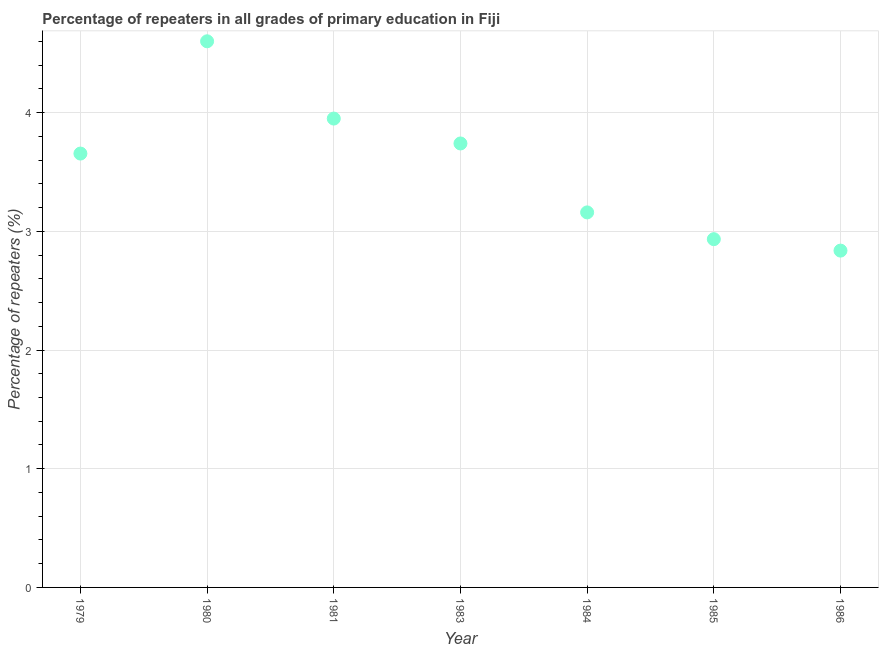What is the percentage of repeaters in primary education in 1983?
Make the answer very short. 3.74. Across all years, what is the maximum percentage of repeaters in primary education?
Ensure brevity in your answer.  4.6. Across all years, what is the minimum percentage of repeaters in primary education?
Give a very brief answer. 2.84. In which year was the percentage of repeaters in primary education maximum?
Offer a very short reply. 1980. In which year was the percentage of repeaters in primary education minimum?
Make the answer very short. 1986. What is the sum of the percentage of repeaters in primary education?
Offer a very short reply. 24.88. What is the difference between the percentage of repeaters in primary education in 1983 and 1986?
Make the answer very short. 0.9. What is the average percentage of repeaters in primary education per year?
Provide a short and direct response. 3.55. What is the median percentage of repeaters in primary education?
Your answer should be very brief. 3.66. What is the ratio of the percentage of repeaters in primary education in 1983 to that in 1984?
Your answer should be compact. 1.18. Is the percentage of repeaters in primary education in 1979 less than that in 1983?
Provide a short and direct response. Yes. Is the difference between the percentage of repeaters in primary education in 1981 and 1986 greater than the difference between any two years?
Keep it short and to the point. No. What is the difference between the highest and the second highest percentage of repeaters in primary education?
Your answer should be compact. 0.65. Is the sum of the percentage of repeaters in primary education in 1984 and 1985 greater than the maximum percentage of repeaters in primary education across all years?
Your answer should be very brief. Yes. What is the difference between the highest and the lowest percentage of repeaters in primary education?
Your response must be concise. 1.76. In how many years, is the percentage of repeaters in primary education greater than the average percentage of repeaters in primary education taken over all years?
Provide a succinct answer. 4. Does the percentage of repeaters in primary education monotonically increase over the years?
Offer a very short reply. No. How many dotlines are there?
Your answer should be very brief. 1. What is the difference between two consecutive major ticks on the Y-axis?
Provide a succinct answer. 1. Does the graph contain any zero values?
Ensure brevity in your answer.  No. Does the graph contain grids?
Your answer should be very brief. Yes. What is the title of the graph?
Provide a short and direct response. Percentage of repeaters in all grades of primary education in Fiji. What is the label or title of the Y-axis?
Your answer should be compact. Percentage of repeaters (%). What is the Percentage of repeaters (%) in 1979?
Offer a very short reply. 3.66. What is the Percentage of repeaters (%) in 1980?
Provide a short and direct response. 4.6. What is the Percentage of repeaters (%) in 1981?
Ensure brevity in your answer.  3.95. What is the Percentage of repeaters (%) in 1983?
Ensure brevity in your answer.  3.74. What is the Percentage of repeaters (%) in 1984?
Offer a terse response. 3.16. What is the Percentage of repeaters (%) in 1985?
Make the answer very short. 2.93. What is the Percentage of repeaters (%) in 1986?
Your answer should be compact. 2.84. What is the difference between the Percentage of repeaters (%) in 1979 and 1980?
Ensure brevity in your answer.  -0.95. What is the difference between the Percentage of repeaters (%) in 1979 and 1981?
Your answer should be very brief. -0.29. What is the difference between the Percentage of repeaters (%) in 1979 and 1983?
Provide a short and direct response. -0.09. What is the difference between the Percentage of repeaters (%) in 1979 and 1984?
Provide a short and direct response. 0.5. What is the difference between the Percentage of repeaters (%) in 1979 and 1985?
Your response must be concise. 0.72. What is the difference between the Percentage of repeaters (%) in 1979 and 1986?
Provide a succinct answer. 0.82. What is the difference between the Percentage of repeaters (%) in 1980 and 1981?
Offer a terse response. 0.65. What is the difference between the Percentage of repeaters (%) in 1980 and 1983?
Provide a succinct answer. 0.86. What is the difference between the Percentage of repeaters (%) in 1980 and 1984?
Make the answer very short. 1.44. What is the difference between the Percentage of repeaters (%) in 1980 and 1985?
Make the answer very short. 1.67. What is the difference between the Percentage of repeaters (%) in 1980 and 1986?
Your answer should be compact. 1.76. What is the difference between the Percentage of repeaters (%) in 1981 and 1983?
Make the answer very short. 0.21. What is the difference between the Percentage of repeaters (%) in 1981 and 1984?
Ensure brevity in your answer.  0.79. What is the difference between the Percentage of repeaters (%) in 1981 and 1985?
Keep it short and to the point. 1.02. What is the difference between the Percentage of repeaters (%) in 1981 and 1986?
Give a very brief answer. 1.11. What is the difference between the Percentage of repeaters (%) in 1983 and 1984?
Provide a succinct answer. 0.58. What is the difference between the Percentage of repeaters (%) in 1983 and 1985?
Your response must be concise. 0.81. What is the difference between the Percentage of repeaters (%) in 1983 and 1986?
Give a very brief answer. 0.9. What is the difference between the Percentage of repeaters (%) in 1984 and 1985?
Your response must be concise. 0.23. What is the difference between the Percentage of repeaters (%) in 1984 and 1986?
Provide a succinct answer. 0.32. What is the difference between the Percentage of repeaters (%) in 1985 and 1986?
Ensure brevity in your answer.  0.1. What is the ratio of the Percentage of repeaters (%) in 1979 to that in 1980?
Ensure brevity in your answer.  0.79. What is the ratio of the Percentage of repeaters (%) in 1979 to that in 1981?
Offer a terse response. 0.93. What is the ratio of the Percentage of repeaters (%) in 1979 to that in 1984?
Give a very brief answer. 1.16. What is the ratio of the Percentage of repeaters (%) in 1979 to that in 1985?
Provide a short and direct response. 1.25. What is the ratio of the Percentage of repeaters (%) in 1979 to that in 1986?
Make the answer very short. 1.29. What is the ratio of the Percentage of repeaters (%) in 1980 to that in 1981?
Provide a short and direct response. 1.17. What is the ratio of the Percentage of repeaters (%) in 1980 to that in 1983?
Give a very brief answer. 1.23. What is the ratio of the Percentage of repeaters (%) in 1980 to that in 1984?
Provide a succinct answer. 1.46. What is the ratio of the Percentage of repeaters (%) in 1980 to that in 1985?
Make the answer very short. 1.57. What is the ratio of the Percentage of repeaters (%) in 1980 to that in 1986?
Your response must be concise. 1.62. What is the ratio of the Percentage of repeaters (%) in 1981 to that in 1983?
Provide a succinct answer. 1.06. What is the ratio of the Percentage of repeaters (%) in 1981 to that in 1984?
Your answer should be very brief. 1.25. What is the ratio of the Percentage of repeaters (%) in 1981 to that in 1985?
Offer a terse response. 1.35. What is the ratio of the Percentage of repeaters (%) in 1981 to that in 1986?
Provide a short and direct response. 1.39. What is the ratio of the Percentage of repeaters (%) in 1983 to that in 1984?
Offer a very short reply. 1.18. What is the ratio of the Percentage of repeaters (%) in 1983 to that in 1985?
Offer a terse response. 1.27. What is the ratio of the Percentage of repeaters (%) in 1983 to that in 1986?
Make the answer very short. 1.32. What is the ratio of the Percentage of repeaters (%) in 1984 to that in 1985?
Ensure brevity in your answer.  1.08. What is the ratio of the Percentage of repeaters (%) in 1984 to that in 1986?
Offer a very short reply. 1.11. What is the ratio of the Percentage of repeaters (%) in 1985 to that in 1986?
Provide a succinct answer. 1.03. 